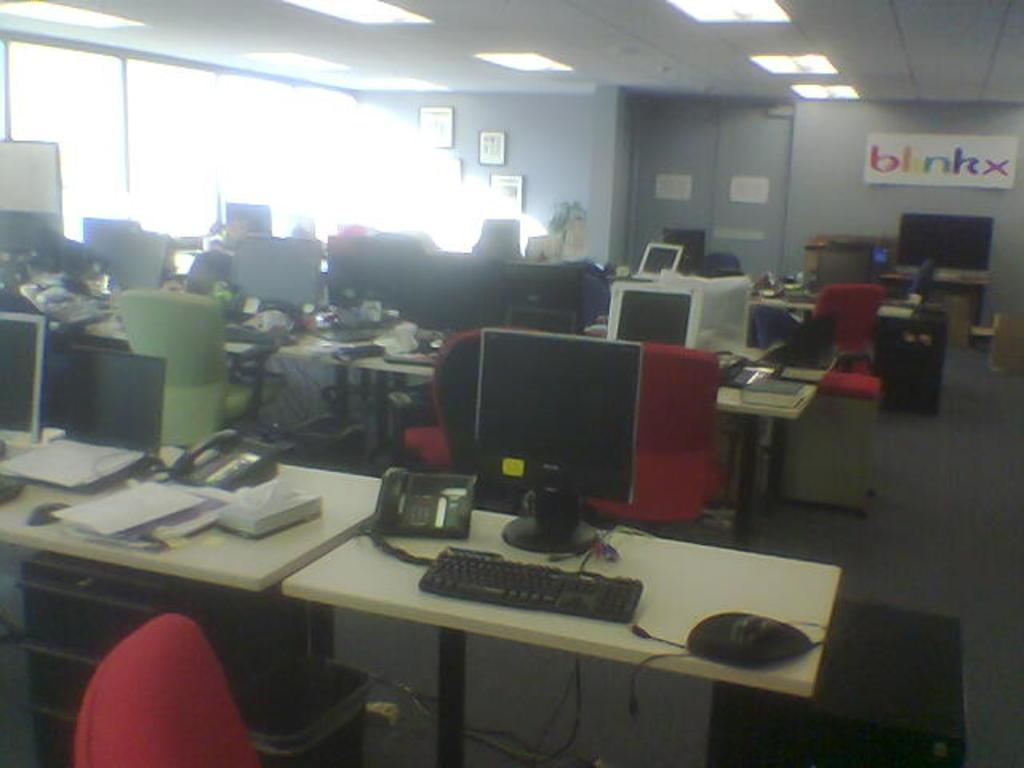<image>
Write a terse but informative summary of the picture. An office has a lot of tables and a sign on the wall with the word blinkx. 